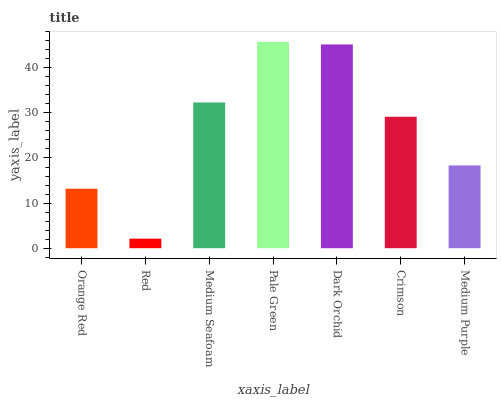Is Red the minimum?
Answer yes or no. Yes. Is Pale Green the maximum?
Answer yes or no. Yes. Is Medium Seafoam the minimum?
Answer yes or no. No. Is Medium Seafoam the maximum?
Answer yes or no. No. Is Medium Seafoam greater than Red?
Answer yes or no. Yes. Is Red less than Medium Seafoam?
Answer yes or no. Yes. Is Red greater than Medium Seafoam?
Answer yes or no. No. Is Medium Seafoam less than Red?
Answer yes or no. No. Is Crimson the high median?
Answer yes or no. Yes. Is Crimson the low median?
Answer yes or no. Yes. Is Red the high median?
Answer yes or no. No. Is Medium Purple the low median?
Answer yes or no. No. 